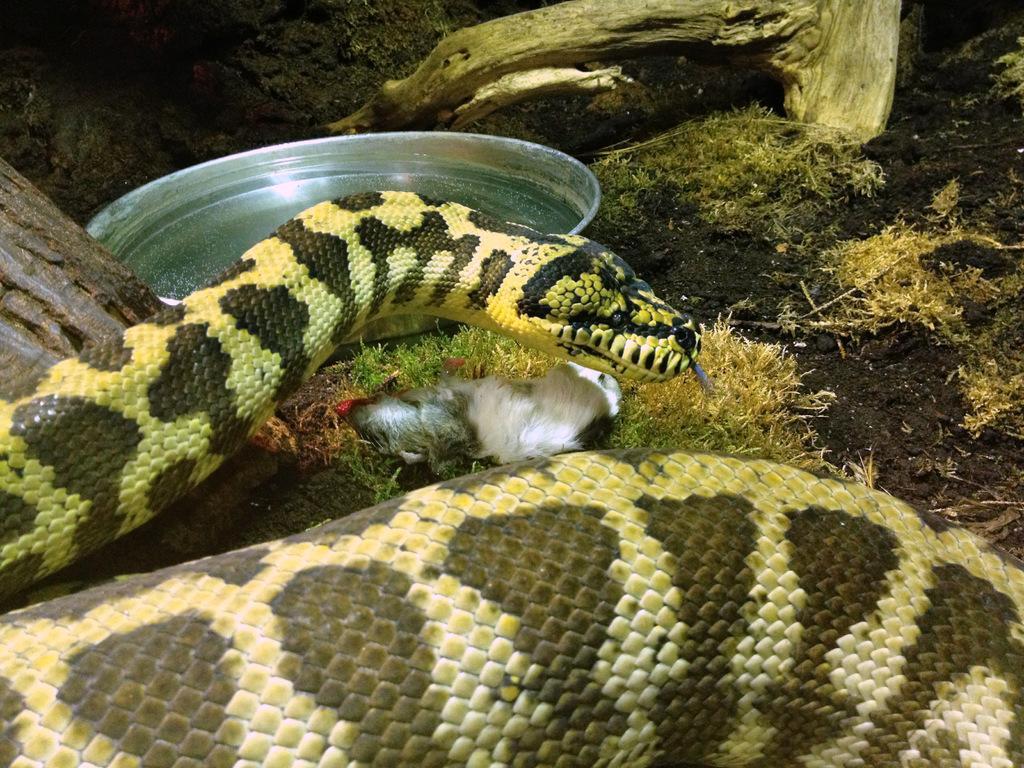How would you summarize this image in a sentence or two? In this picture I can observe a snake which is in black and yellow color. In front of the snake there is a plate on the ground. 